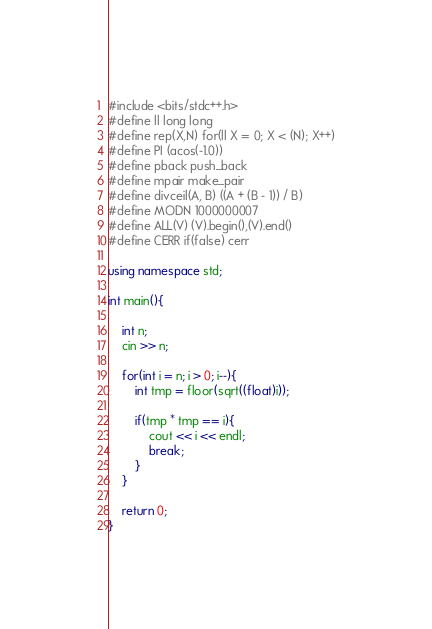<code> <loc_0><loc_0><loc_500><loc_500><_C++_>#include <bits/stdc++.h>
#define ll long long
#define rep(X,N) for(ll X = 0; X < (N); X++)
#define PI (acos(-1.0))
#define pback push_back
#define mpair make_pair
#define divceil(A, B) ((A + (B - 1)) / B)
#define MODN 1000000007
#define ALL(V) (V).begin(),(V).end()
#define CERR if(false) cerr

using namespace std;

int main(){

    int n;
    cin >> n;

    for(int i = n; i > 0; i--){
        int tmp = floor(sqrt((float)i));

        if(tmp * tmp == i){
            cout << i << endl;
            break;
        }
    }

    return 0;
}
</code> 